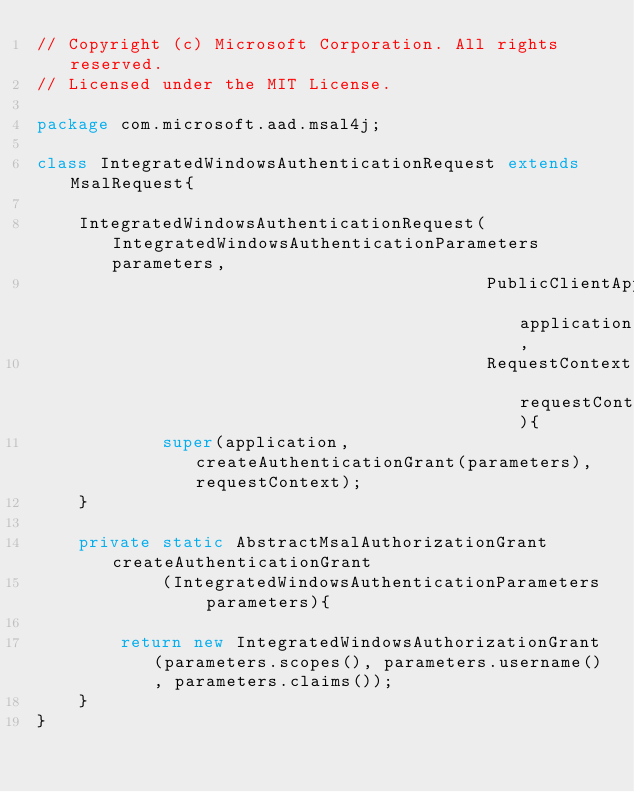<code> <loc_0><loc_0><loc_500><loc_500><_Java_>// Copyright (c) Microsoft Corporation. All rights reserved.
// Licensed under the MIT License.

package com.microsoft.aad.msal4j;

class IntegratedWindowsAuthenticationRequest extends MsalRequest{

    IntegratedWindowsAuthenticationRequest(IntegratedWindowsAuthenticationParameters parameters,
                                           PublicClientApplication application,
                                           RequestContext requestContext){
            super(application, createAuthenticationGrant(parameters), requestContext);
    }

    private static AbstractMsalAuthorizationGrant createAuthenticationGrant
            (IntegratedWindowsAuthenticationParameters parameters){

        return new IntegratedWindowsAuthorizationGrant(parameters.scopes(), parameters.username(), parameters.claims());
    }
}
</code> 